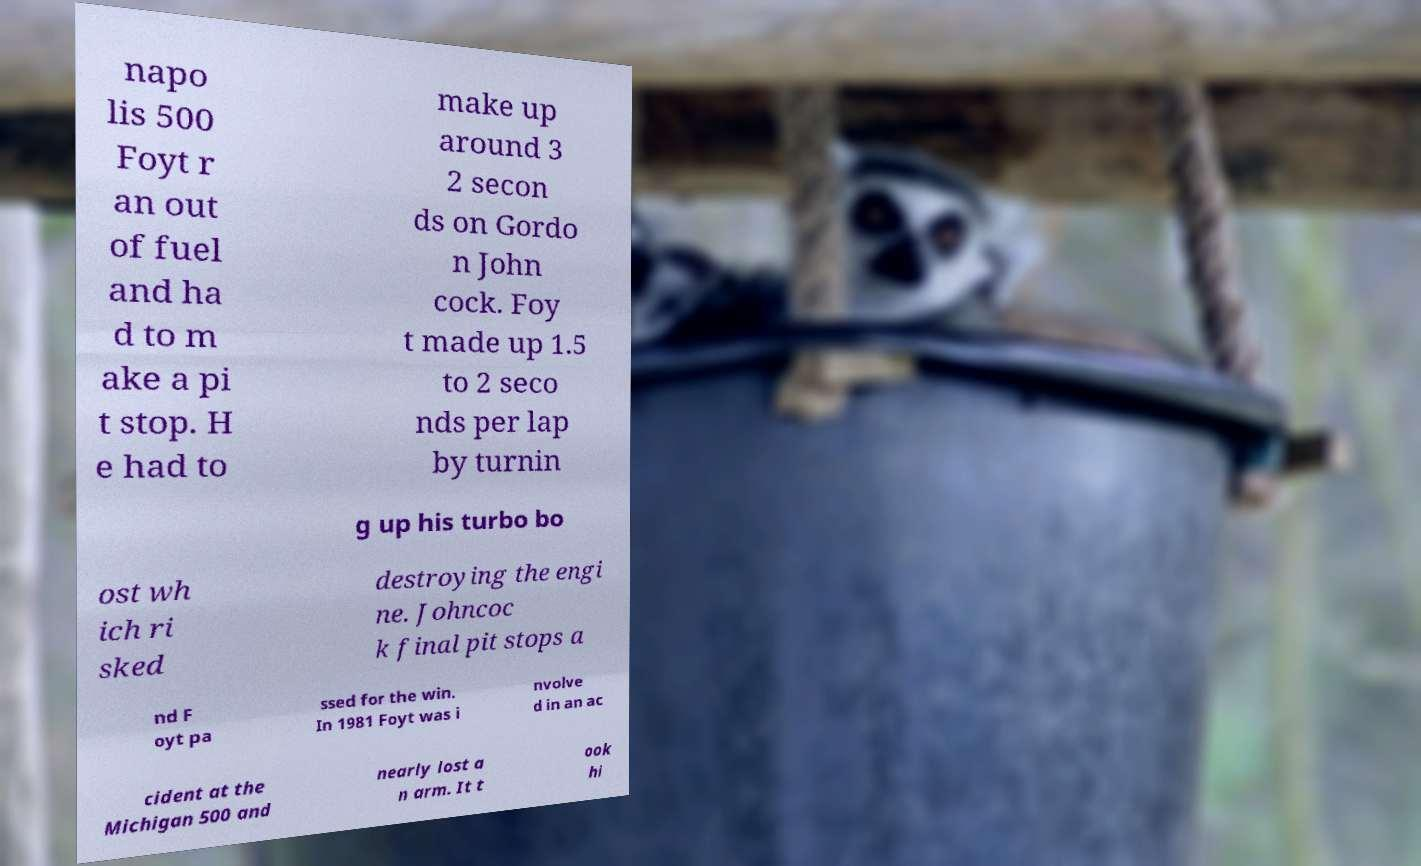Could you assist in decoding the text presented in this image and type it out clearly? napo lis 500 Foyt r an out of fuel and ha d to m ake a pi t stop. H e had to make up around 3 2 secon ds on Gordo n John cock. Foy t made up 1.5 to 2 seco nds per lap by turnin g up his turbo bo ost wh ich ri sked destroying the engi ne. Johncoc k final pit stops a nd F oyt pa ssed for the win. In 1981 Foyt was i nvolve d in an ac cident at the Michigan 500 and nearly lost a n arm. It t ook hi 